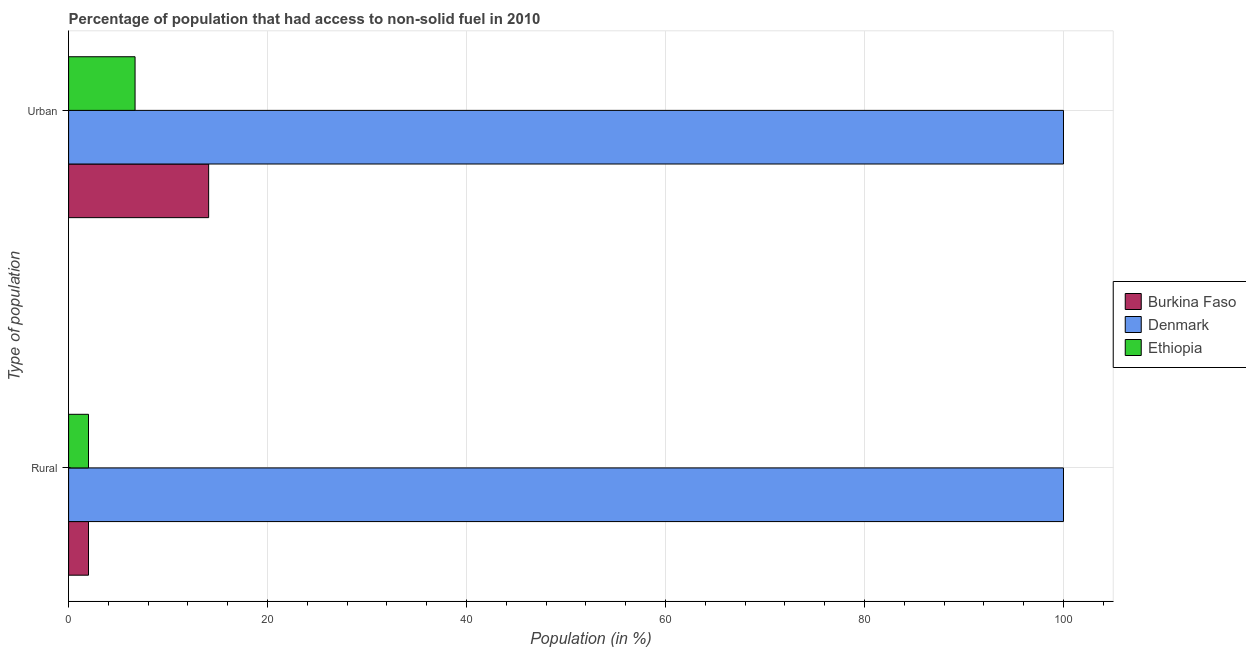How many different coloured bars are there?
Offer a very short reply. 3. How many groups of bars are there?
Keep it short and to the point. 2. What is the label of the 2nd group of bars from the top?
Give a very brief answer. Rural. What is the rural population in Denmark?
Offer a terse response. 100. Across all countries, what is the minimum rural population?
Your response must be concise. 2. In which country was the rural population minimum?
Provide a short and direct response. Burkina Faso. What is the total urban population in the graph?
Keep it short and to the point. 120.76. What is the difference between the urban population in Burkina Faso and that in Ethiopia?
Offer a terse response. 7.4. What is the difference between the urban population in Denmark and the rural population in Ethiopia?
Offer a very short reply. 98. What is the average urban population per country?
Make the answer very short. 40.25. What is the difference between the urban population and rural population in Ethiopia?
Your response must be concise. 4.68. In how many countries, is the rural population greater than 56 %?
Provide a short and direct response. 1. What is the ratio of the rural population in Ethiopia to that in Burkina Faso?
Ensure brevity in your answer.  1. Is the rural population in Burkina Faso less than that in Denmark?
Give a very brief answer. Yes. In how many countries, is the urban population greater than the average urban population taken over all countries?
Your response must be concise. 1. What does the 3rd bar from the top in Rural represents?
Offer a terse response. Burkina Faso. What does the 3rd bar from the bottom in Rural represents?
Offer a terse response. Ethiopia. Are all the bars in the graph horizontal?
Offer a very short reply. Yes. How many countries are there in the graph?
Your answer should be compact. 3. What is the difference between two consecutive major ticks on the X-axis?
Give a very brief answer. 20. Are the values on the major ticks of X-axis written in scientific E-notation?
Keep it short and to the point. No. Does the graph contain grids?
Keep it short and to the point. Yes. How are the legend labels stacked?
Your answer should be very brief. Vertical. What is the title of the graph?
Make the answer very short. Percentage of population that had access to non-solid fuel in 2010. Does "Benin" appear as one of the legend labels in the graph?
Offer a terse response. No. What is the label or title of the X-axis?
Keep it short and to the point. Population (in %). What is the label or title of the Y-axis?
Your answer should be compact. Type of population. What is the Population (in %) in Burkina Faso in Rural?
Provide a succinct answer. 2. What is the Population (in %) in Ethiopia in Rural?
Provide a short and direct response. 2. What is the Population (in %) of Burkina Faso in Urban?
Offer a terse response. 14.08. What is the Population (in %) in Denmark in Urban?
Ensure brevity in your answer.  100. What is the Population (in %) of Ethiopia in Urban?
Make the answer very short. 6.68. Across all Type of population, what is the maximum Population (in %) in Burkina Faso?
Provide a short and direct response. 14.08. Across all Type of population, what is the maximum Population (in %) in Denmark?
Provide a short and direct response. 100. Across all Type of population, what is the maximum Population (in %) in Ethiopia?
Your response must be concise. 6.68. Across all Type of population, what is the minimum Population (in %) of Burkina Faso?
Keep it short and to the point. 2. Across all Type of population, what is the minimum Population (in %) in Denmark?
Your answer should be very brief. 100. Across all Type of population, what is the minimum Population (in %) of Ethiopia?
Offer a terse response. 2. What is the total Population (in %) in Burkina Faso in the graph?
Your response must be concise. 16.08. What is the total Population (in %) of Denmark in the graph?
Provide a succinct answer. 200. What is the total Population (in %) of Ethiopia in the graph?
Make the answer very short. 8.68. What is the difference between the Population (in %) of Burkina Faso in Rural and that in Urban?
Make the answer very short. -12.08. What is the difference between the Population (in %) of Ethiopia in Rural and that in Urban?
Provide a succinct answer. -4.68. What is the difference between the Population (in %) in Burkina Faso in Rural and the Population (in %) in Denmark in Urban?
Make the answer very short. -98. What is the difference between the Population (in %) in Burkina Faso in Rural and the Population (in %) in Ethiopia in Urban?
Give a very brief answer. -4.68. What is the difference between the Population (in %) in Denmark in Rural and the Population (in %) in Ethiopia in Urban?
Give a very brief answer. 93.32. What is the average Population (in %) of Burkina Faso per Type of population?
Your answer should be compact. 8.04. What is the average Population (in %) in Denmark per Type of population?
Make the answer very short. 100. What is the average Population (in %) of Ethiopia per Type of population?
Make the answer very short. 4.34. What is the difference between the Population (in %) of Burkina Faso and Population (in %) of Denmark in Rural?
Give a very brief answer. -98. What is the difference between the Population (in %) in Burkina Faso and Population (in %) in Ethiopia in Rural?
Give a very brief answer. 0. What is the difference between the Population (in %) of Burkina Faso and Population (in %) of Denmark in Urban?
Ensure brevity in your answer.  -85.92. What is the difference between the Population (in %) of Burkina Faso and Population (in %) of Ethiopia in Urban?
Your answer should be very brief. 7.4. What is the difference between the Population (in %) in Denmark and Population (in %) in Ethiopia in Urban?
Offer a terse response. 93.32. What is the ratio of the Population (in %) of Burkina Faso in Rural to that in Urban?
Offer a very short reply. 0.14. What is the ratio of the Population (in %) of Denmark in Rural to that in Urban?
Offer a terse response. 1. What is the ratio of the Population (in %) in Ethiopia in Rural to that in Urban?
Offer a terse response. 0.3. What is the difference between the highest and the second highest Population (in %) in Burkina Faso?
Give a very brief answer. 12.08. What is the difference between the highest and the second highest Population (in %) in Ethiopia?
Give a very brief answer. 4.68. What is the difference between the highest and the lowest Population (in %) in Burkina Faso?
Ensure brevity in your answer.  12.08. What is the difference between the highest and the lowest Population (in %) of Denmark?
Provide a short and direct response. 0. What is the difference between the highest and the lowest Population (in %) in Ethiopia?
Your answer should be very brief. 4.68. 